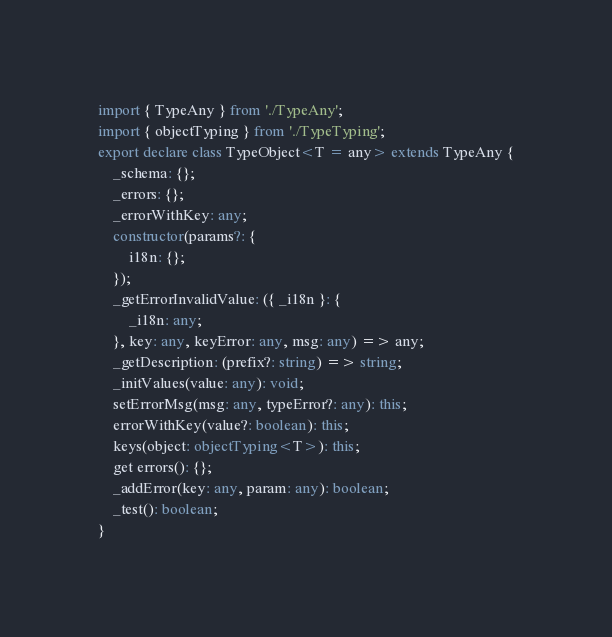<code> <loc_0><loc_0><loc_500><loc_500><_TypeScript_>import { TypeAny } from './TypeAny';
import { objectTyping } from './TypeTyping';
export declare class TypeObject<T = any> extends TypeAny {
    _schema: {};
    _errors: {};
    _errorWithKey: any;
    constructor(params?: {
        i18n: {};
    });
    _getErrorInvalidValue: ({ _i18n }: {
        _i18n: any;
    }, key: any, keyError: any, msg: any) => any;
    _getDescription: (prefix?: string) => string;
    _initValues(value: any): void;
    setErrorMsg(msg: any, typeError?: any): this;
    errorWithKey(value?: boolean): this;
    keys(object: objectTyping<T>): this;
    get errors(): {};
    _addError(key: any, param: any): boolean;
    _test(): boolean;
}
</code> 